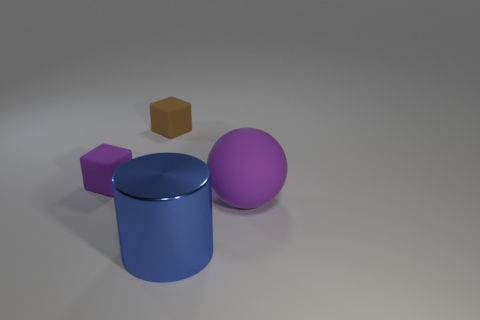Add 2 gray cylinders. How many objects exist? 6 Subtract all cylinders. How many objects are left? 3 Add 1 metal cylinders. How many metal cylinders exist? 2 Subtract 0 green cubes. How many objects are left? 4 Subtract all brown blocks. Subtract all blue metallic cylinders. How many objects are left? 2 Add 4 blue cylinders. How many blue cylinders are left? 5 